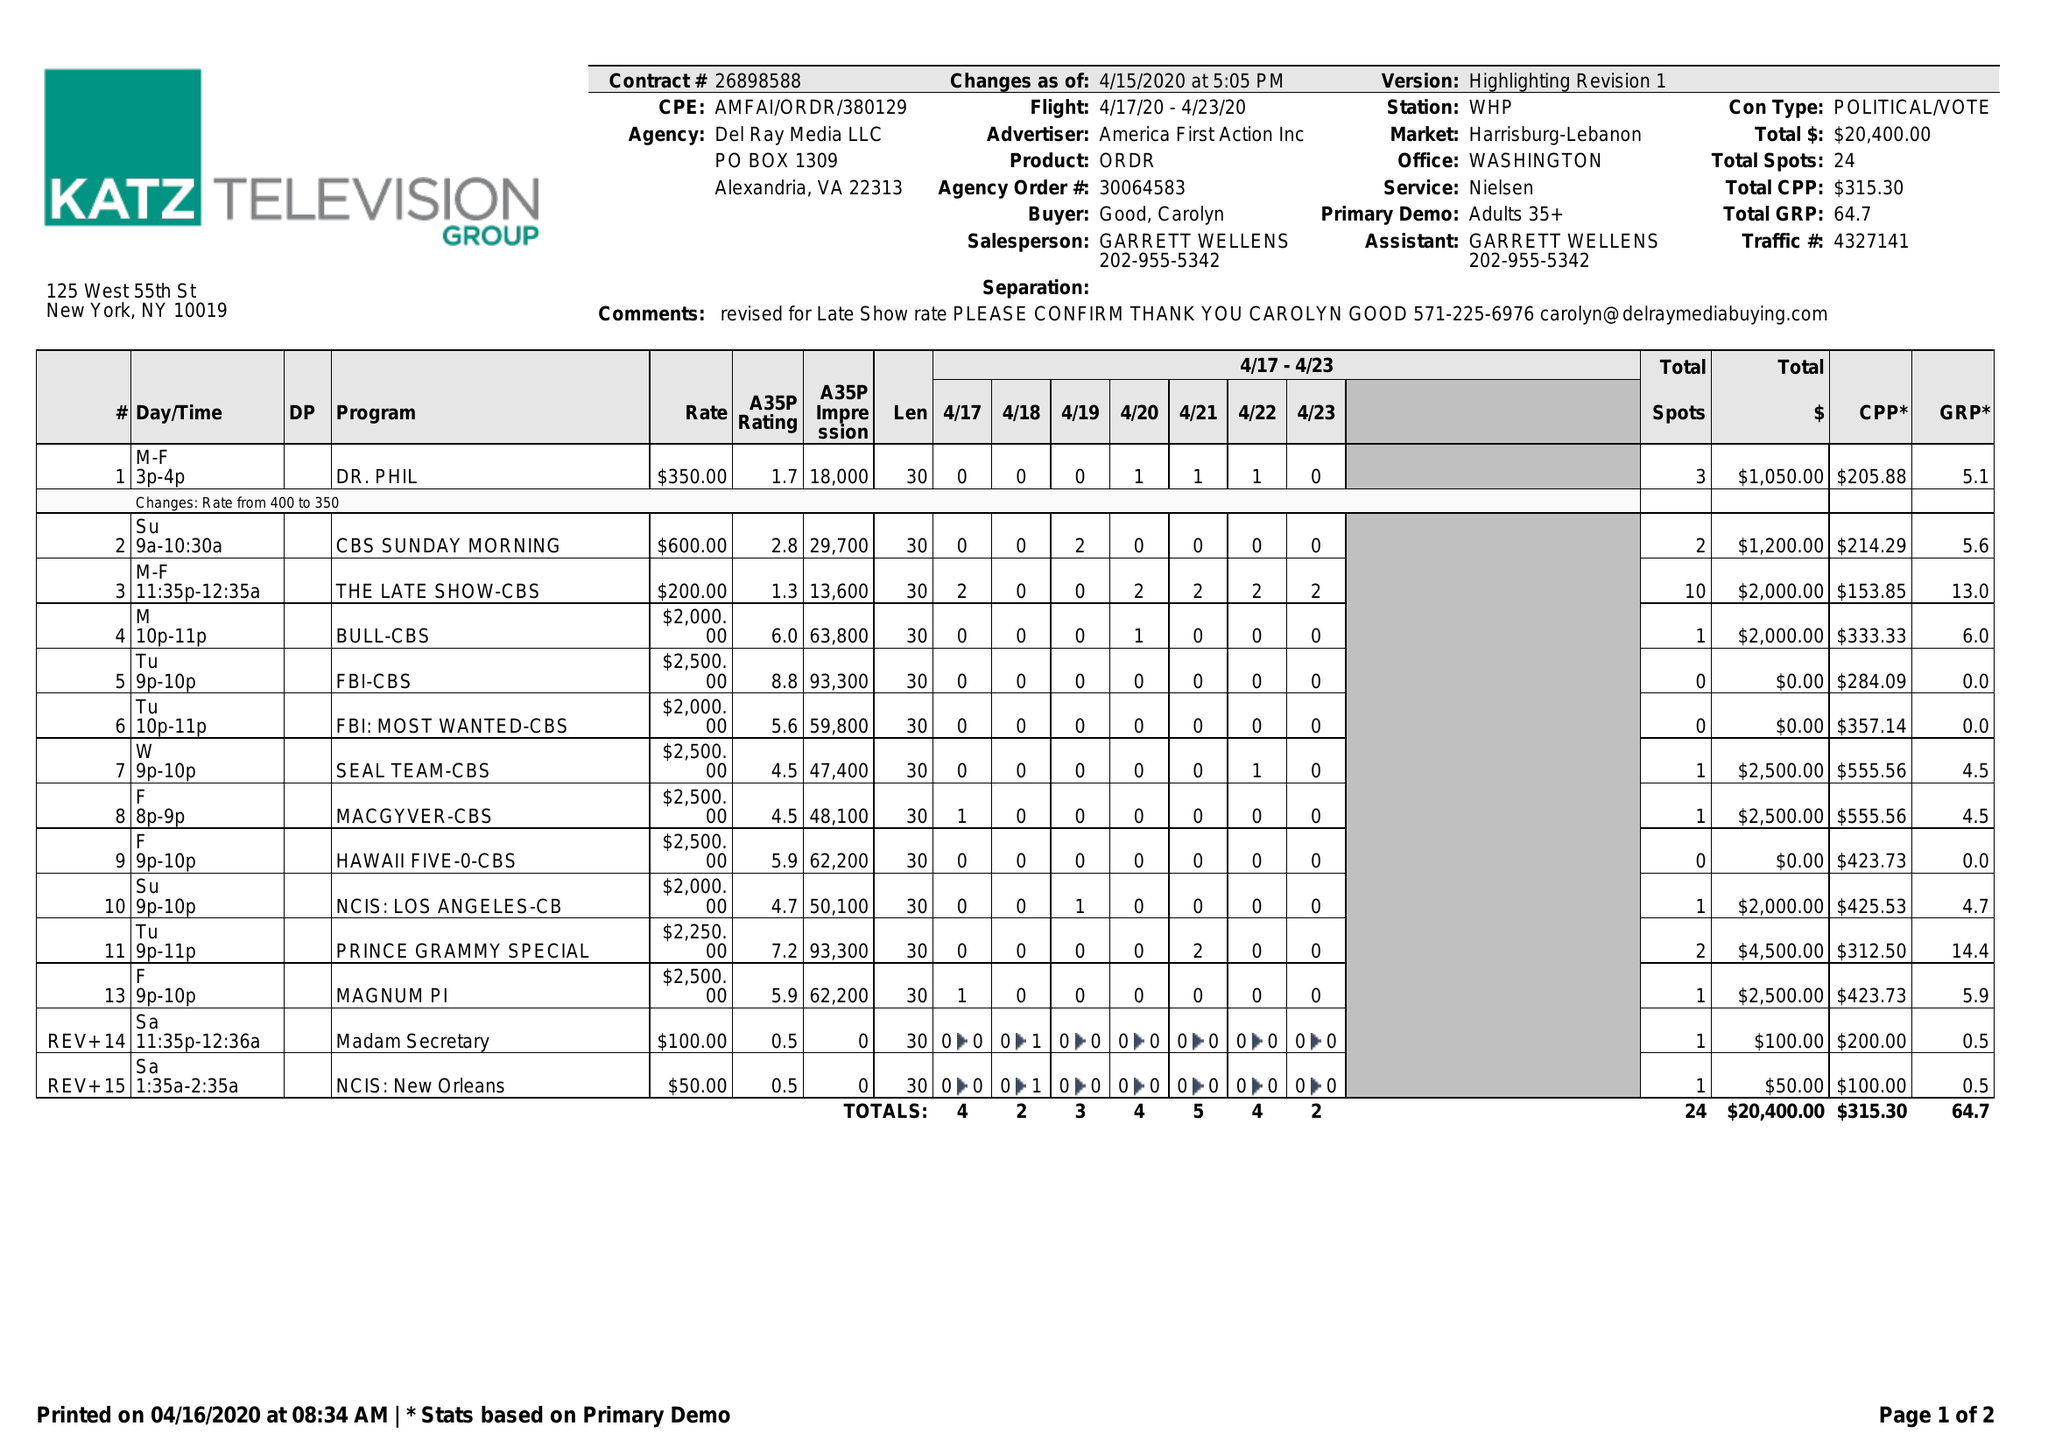What is the value for the gross_amount?
Answer the question using a single word or phrase. 20400.00 